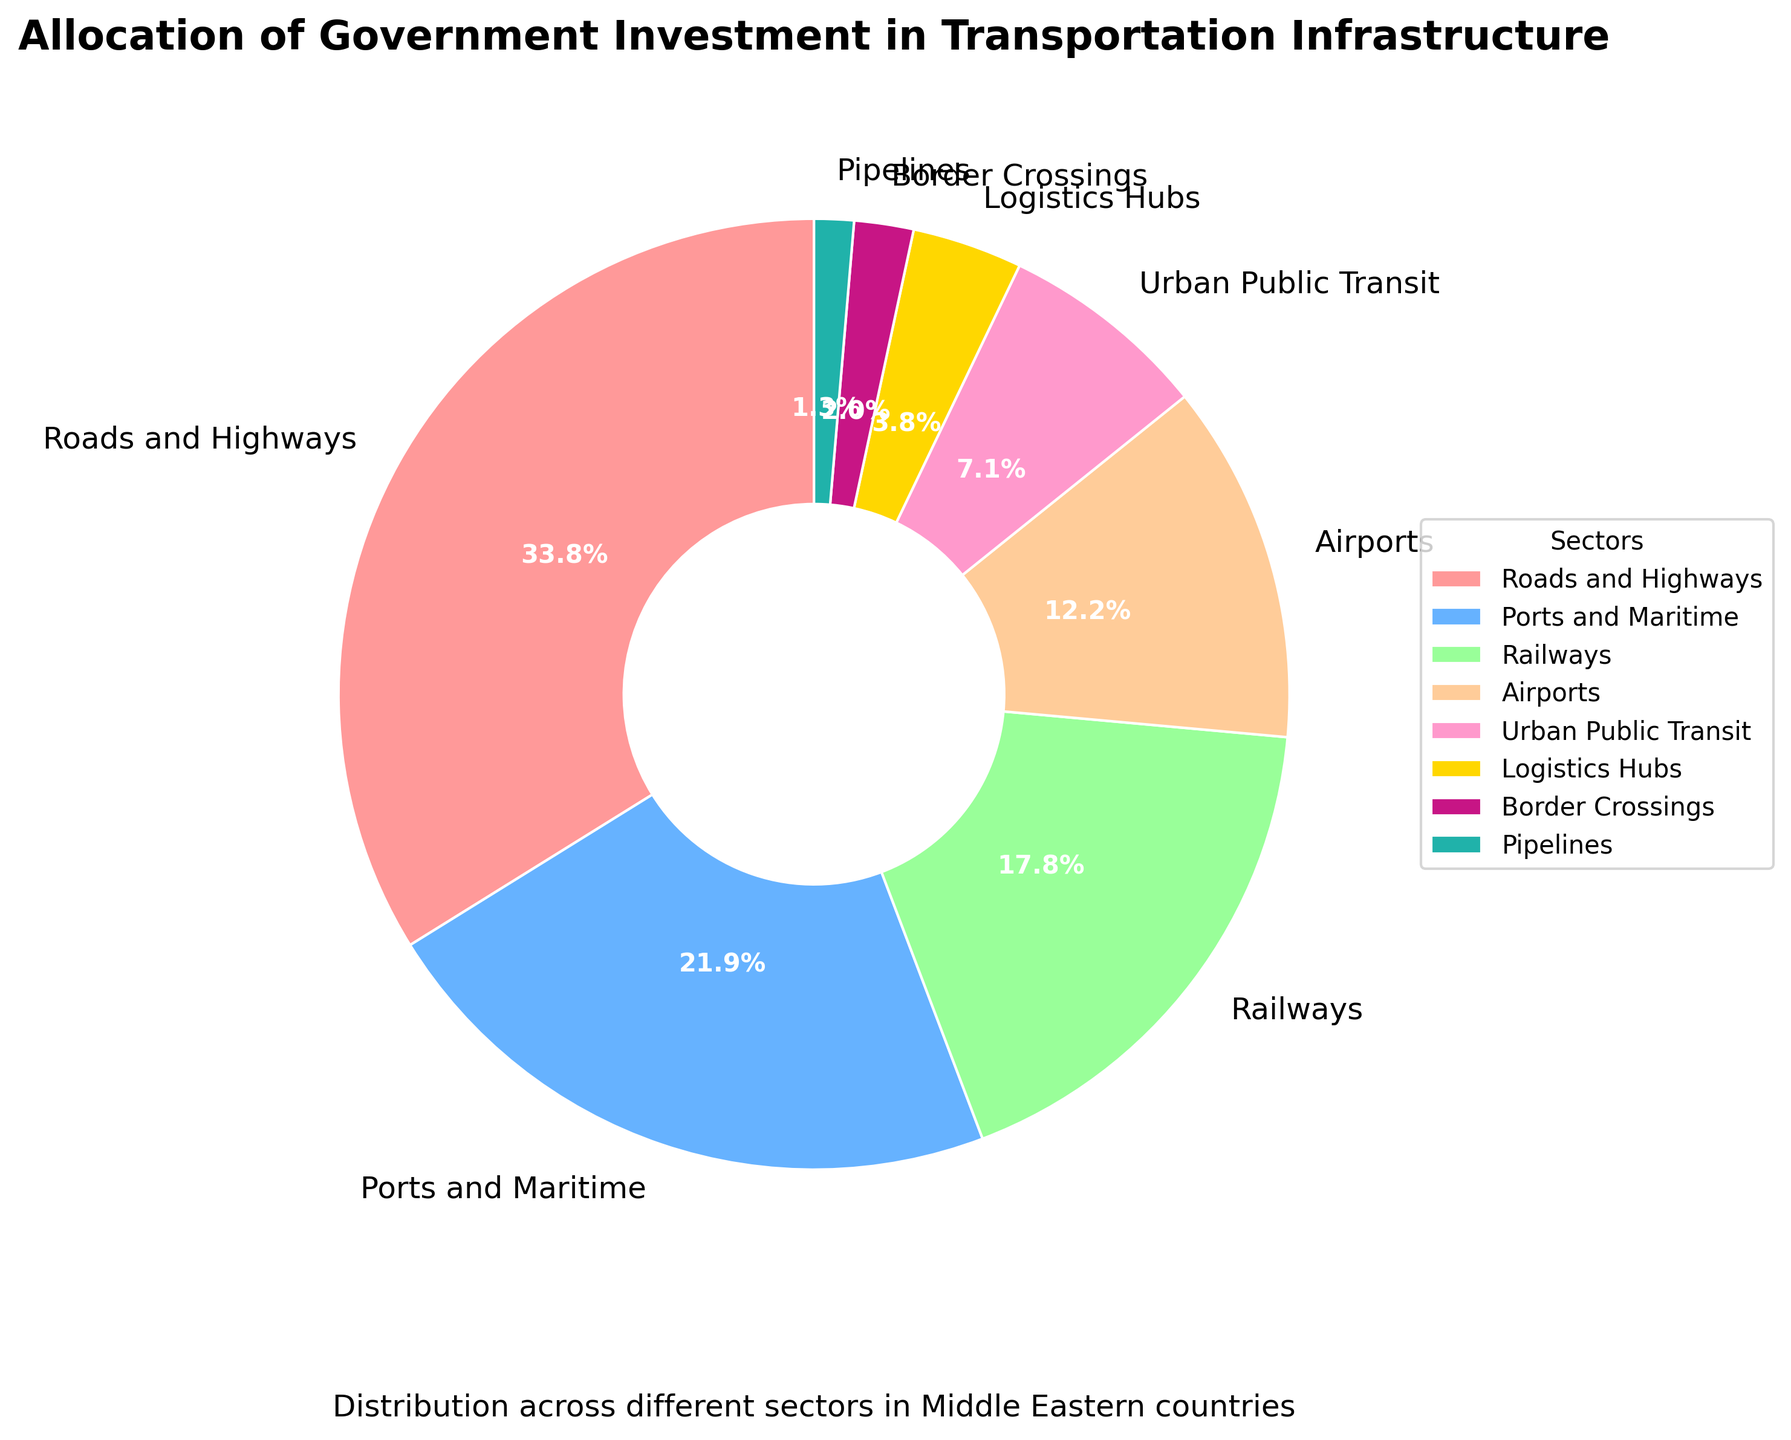What sector receives the highest percentage of government investment? The pie chart visually shows sectors and their corresponding percentages of government investment at a glance. Roads and Highways, with the largest slice at 35.2%, receive the highest percentage of investment.
Answer: Roads and Highways Which sector has the lowest percentage of government investment? The pie chart identifies each sector's investment percentage and their corresponding slices. Pipelines, with the smallest slice, have the lowest investment at 1.4%.
Answer: Pipelines How much more percentage is allocated to Ports and Maritime compared to Railways? By looking at the pie chart, Ports and Maritime have a 22.8% investment and Railways have 18.5%. Subtract the two: 22.8% - 18.5% = 4.3%.
Answer: 4.3% What is the combined investment percentage for Airports and Urban Public Transit? Airports have a 12.7% investment and Urban Public Transit has 7.4%. Add the two percentages: 12.7% + 7.4% = 20.1%.
Answer: 20.1% Are Logistics Hubs allocated more investment than Border Crossings? The pie chart shows that Logistics Hubs have 3.9% investment, while Border Crossings have 2.1%. Since 3.9% is greater than 2.1%, Logistics Hubs receive more investment.
Answer: Yes Which sector has nearly double the percentage investment of Urban Public Transit? Urban Public Transit is allocated 7.4%. Nearly double of 7.4% would be around 14.8%. Airports have 12.7%, which is the closest, though it is not strictly double.
Answer: Airports What is the difference in investment percentage between the highest and the lowest-funded sectors? The highest-funded sector is Roads and Highways at 35.2%, and the lowest-funded is Pipelines at 1.4%. The difference is 35.2% - 1.4% = 33.8%.
Answer: 33.8% How does the investment in Railways compare to the investment in Airports and Border Crossings put together? Railway investment is 18.5%. Airports have 12.7%, and Border Crossings have 2.1%, combined: 12.7% + 2.1% = 14.8%. Since 18.5% is greater than 14.8%, Railways receive more investment.
Answer: More 